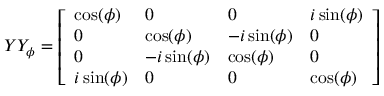<formula> <loc_0><loc_0><loc_500><loc_500>Y Y _ { \phi } = { \left [ \begin{array} { l l l l } { \cos ( \phi ) } & { 0 } & { 0 } & { i \sin ( \phi ) } \\ { 0 } & { \cos ( \phi ) } & { - i \sin ( \phi ) } & { 0 } \\ { 0 } & { - i \sin ( \phi ) } & { \cos ( \phi ) } & { 0 } \\ { i \sin ( \phi ) } & { 0 } & { 0 } & { \cos ( \phi ) } \end{array} \right ] }</formula> 